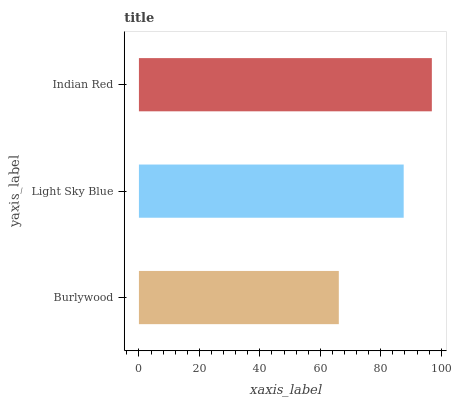Is Burlywood the minimum?
Answer yes or no. Yes. Is Indian Red the maximum?
Answer yes or no. Yes. Is Light Sky Blue the minimum?
Answer yes or no. No. Is Light Sky Blue the maximum?
Answer yes or no. No. Is Light Sky Blue greater than Burlywood?
Answer yes or no. Yes. Is Burlywood less than Light Sky Blue?
Answer yes or no. Yes. Is Burlywood greater than Light Sky Blue?
Answer yes or no. No. Is Light Sky Blue less than Burlywood?
Answer yes or no. No. Is Light Sky Blue the high median?
Answer yes or no. Yes. Is Light Sky Blue the low median?
Answer yes or no. Yes. Is Indian Red the high median?
Answer yes or no. No. Is Indian Red the low median?
Answer yes or no. No. 